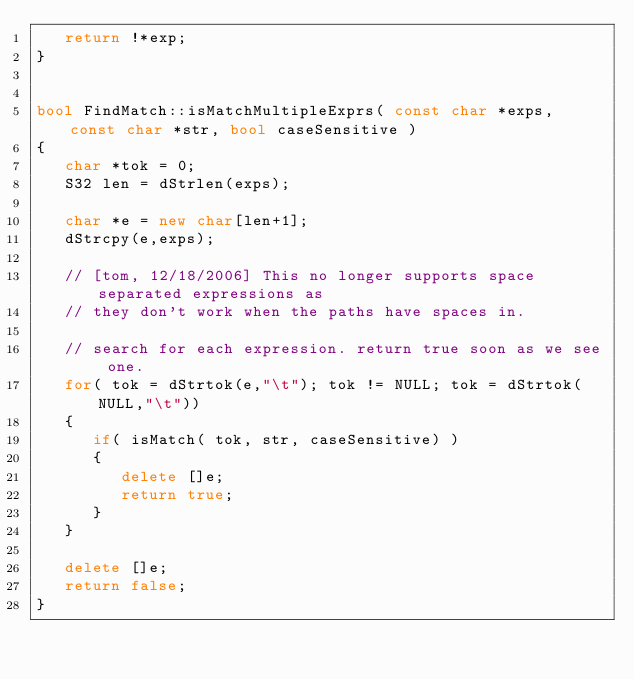Convert code to text. <code><loc_0><loc_0><loc_500><loc_500><_C++_>   return !*exp;
}


bool FindMatch::isMatchMultipleExprs( const char *exps, const char *str, bool caseSensitive )
{
   char *tok = 0;
   S32 len = dStrlen(exps);

   char *e = new char[len+1];
   dStrcpy(e,exps);

   // [tom, 12/18/2006] This no longer supports space separated expressions as
   // they don't work when the paths have spaces in.

   // search for each expression. return true soon as we see one.
   for( tok = dStrtok(e,"\t"); tok != NULL; tok = dStrtok(NULL,"\t"))
   {
      if( isMatch( tok, str, caseSensitive) )
      {
         delete []e;
         return true;
      }
   }

   delete []e;
   return false;
}
</code> 